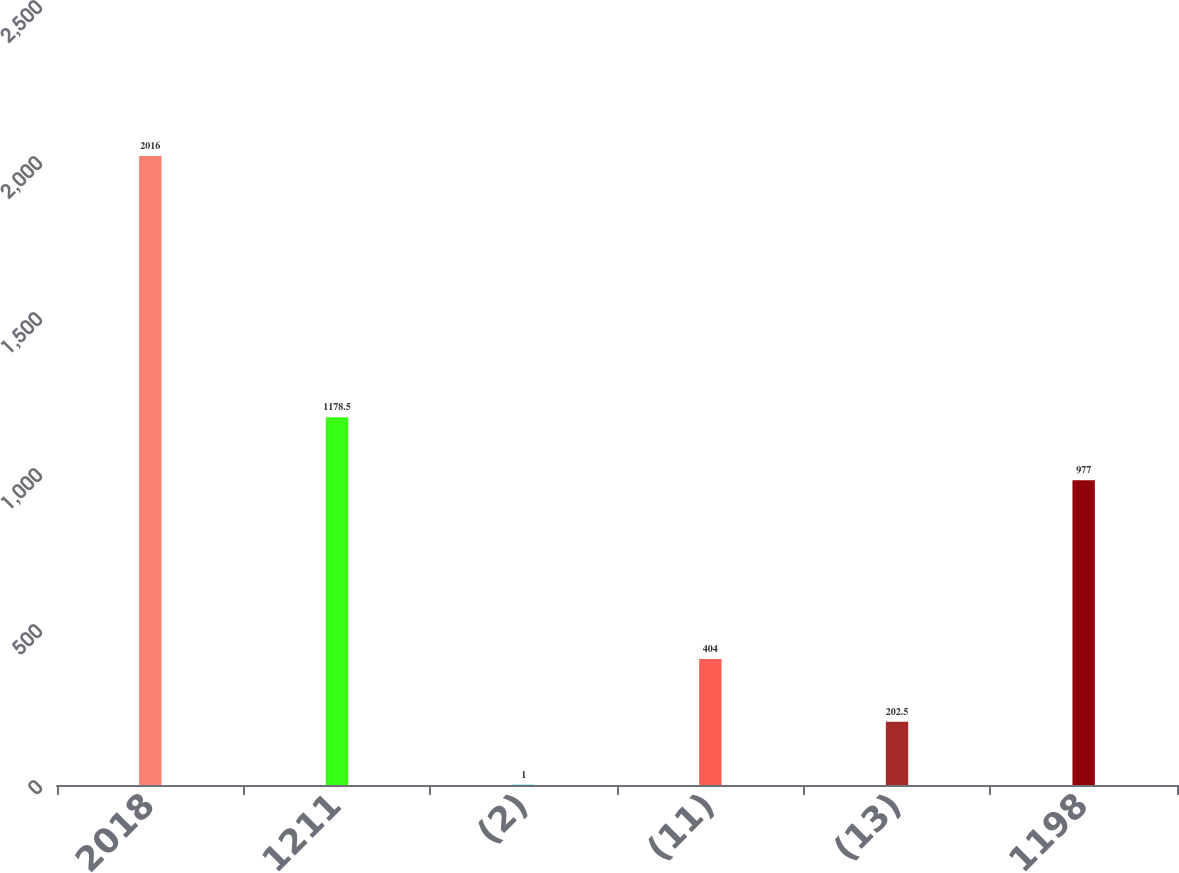Convert chart to OTSL. <chart><loc_0><loc_0><loc_500><loc_500><bar_chart><fcel>2018<fcel>1211<fcel>(2)<fcel>(11)<fcel>(13)<fcel>1198<nl><fcel>2016<fcel>1178.5<fcel>1<fcel>404<fcel>202.5<fcel>977<nl></chart> 